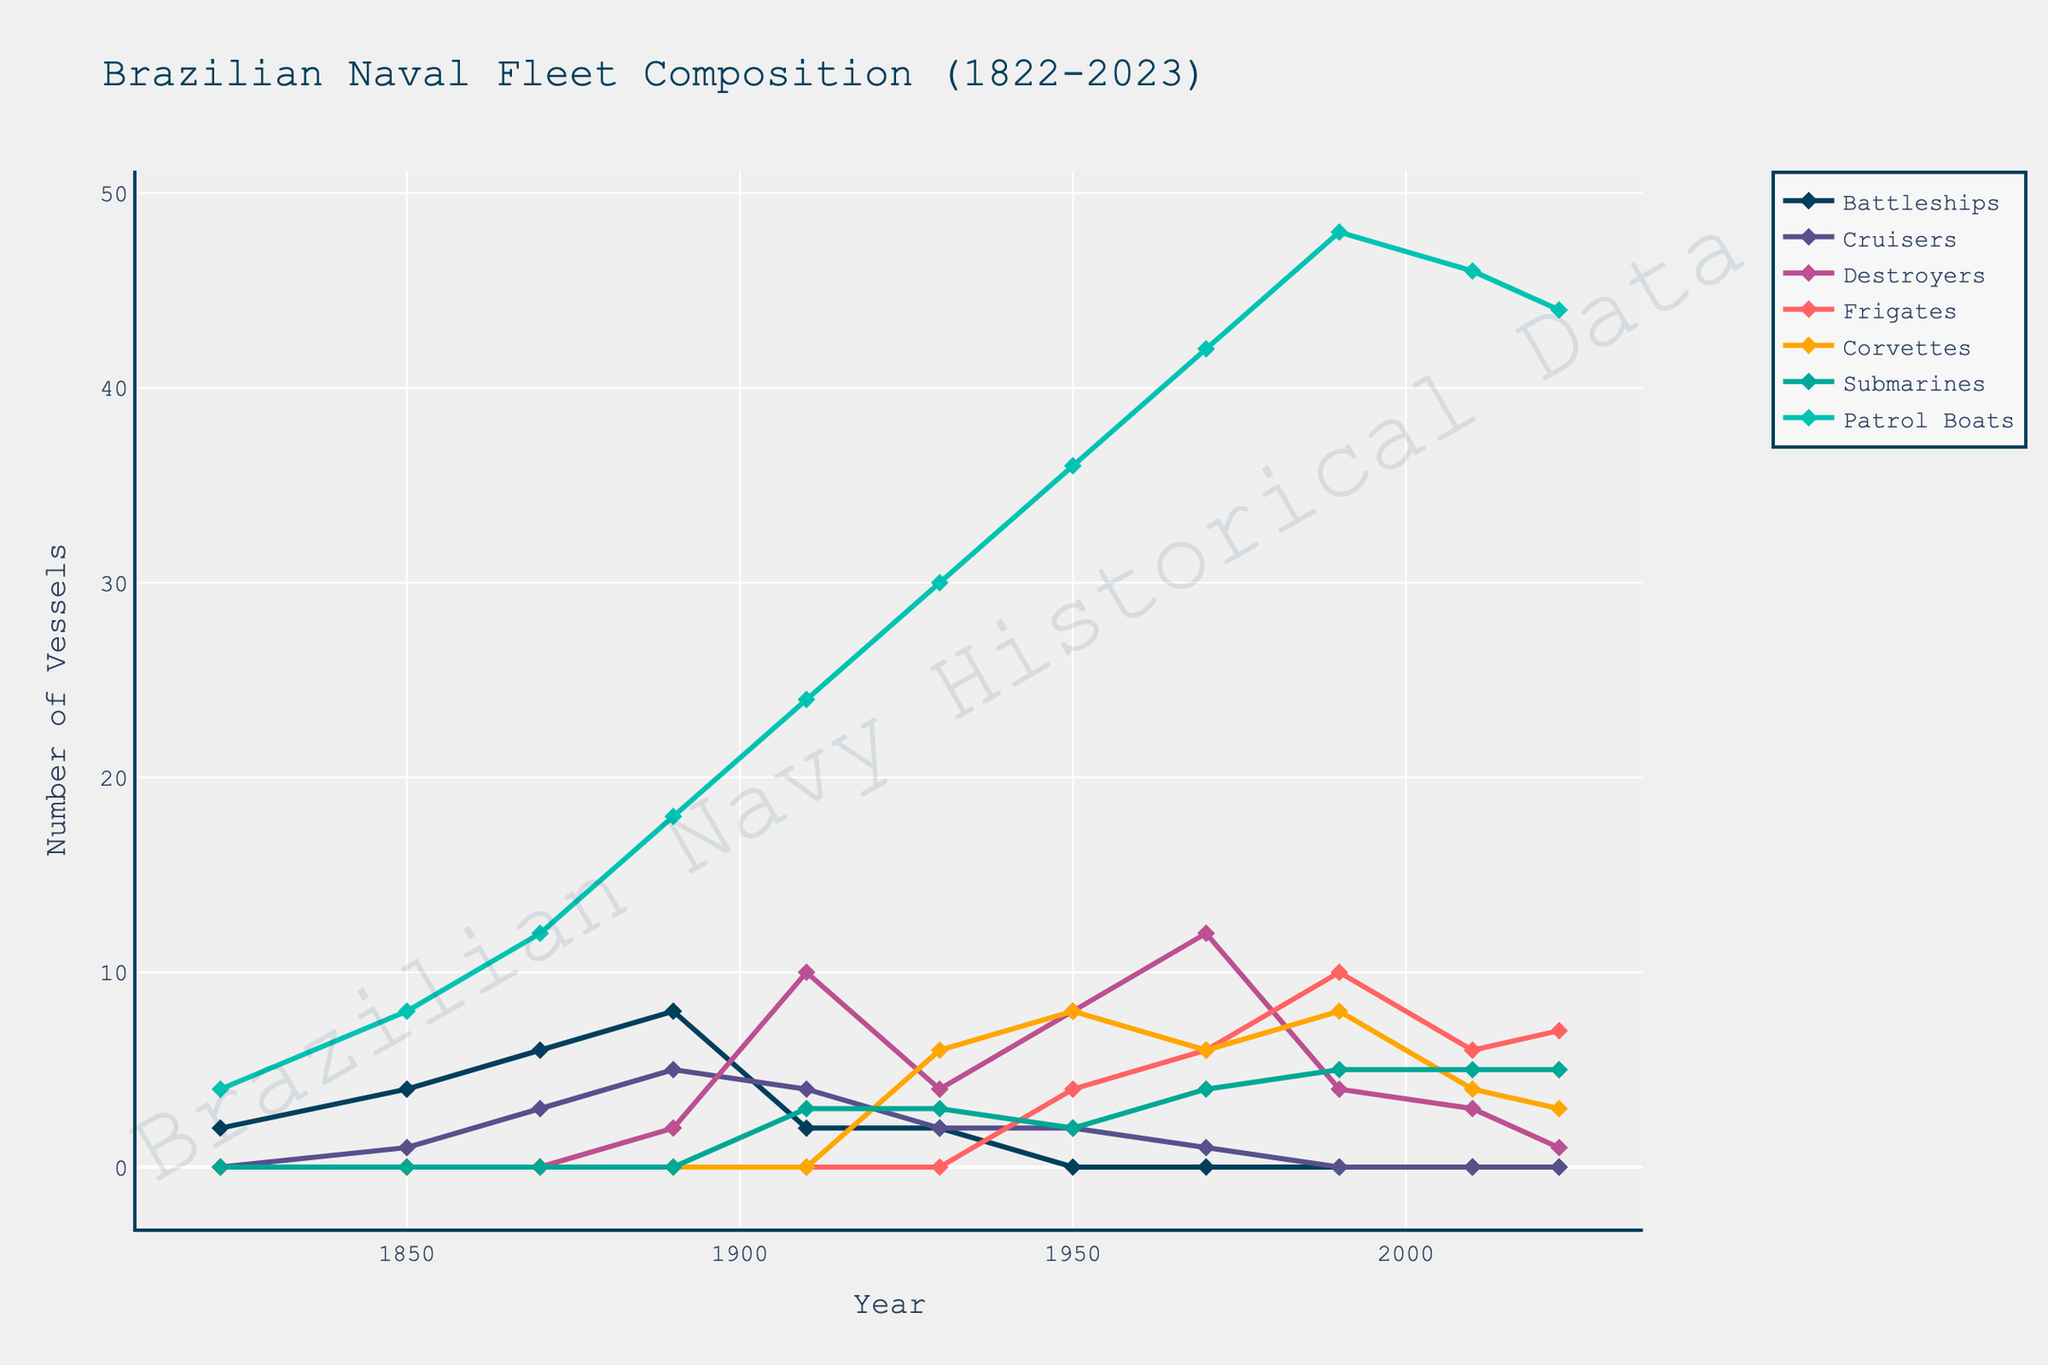What year did the number of cruisers reach its peak? The number of cruisers reached its highest value in 1890 and 1910, at 5 and 4, respectively.
Answer: 1890 Which vessel type had the most consistent increase from 1822 to 2023? To determine the most consistent increase, observe which vessel type shows a steady growth over time without significant drops. Patrol Boats show a steady increase from 4 in 1822 to 44 in 2023, without major fluctuations.
Answer: Patrol Boats What is the sum of Frigates and Corvettes in 1990? In 1990, there were 10 Frigates and 8 Corvettes. Adding these together: 10 + 8 = 18.
Answer: 18 Between which two decades was the greatest decrease in the number of Battleships observed? Battleships fell drastically from 1910 (2) to 1950 (0), showing the largest decline between any two decades in fleet history.
Answer: Between 1910 and 1950 Which vessel type started to emerge around the 1930s and grew significantly later? Submarines emerged in 1910 with 3 and grew notably to 5 by 2023. They show increasing presence across the dataset from their introduction.
Answer: Submarines How does the fleet composition in 1930 compare to that in 1950? In 1930, the fleet had 2 Battleships, 2 Cruisers, 4 Destroyers, 6 Corvettes, 3 Submarines, and 30 Patrol Boats. By 1950, the Battleships were gone, and the fleet included 2 Cruisers, 8 Destroyers, 4 Frigates, 8 Corvettes, 2 Submarines, and 36 Patrol Boats. Notably, Patrol Boats increased from 30 to 36, and Frigates were introduced.
Answer: 1930 fleet had fewer Frigates and Patrol Boats than in 1950 Which vessel type declined the most by absolute number from its peak to 2023? Battleships reached their peak at 8 in 1890, but decreased to 0 by 2023, showing the largest decline by absolute number (-8).
Answer: Battleships When did Destroyers reach their maximum count? The graph shows Destroyers peaked at 12 in 1970, which is their highest count throughout the period.
Answer: 1970 What is the average number of Submarines from the year they first appeared until 2023? Submarines first appeared in 1910. The counts are: 3, 3, 2, 4, 5, 5, averaging (3+3+2+4+5+5)/6 = 22/6.
Answer: 3.67 What is the trend for Patrol Boats from 1822 to 2023? Patrol Boats have shown a consistent increase from 4 in 1822 to 44 in 2023, implying a growing trend with no major reductions over the years.
Answer: Increasing trend 